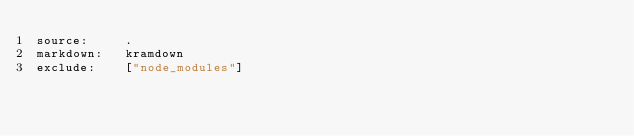Convert code to text. <code><loc_0><loc_0><loc_500><loc_500><_YAML_>source:		.
markdown:	kramdown
exclude:	["node_modules"]</code> 